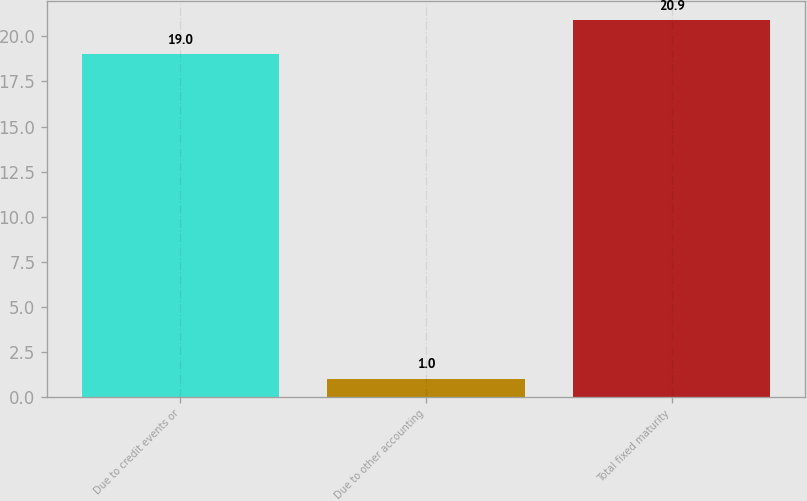Convert chart to OTSL. <chart><loc_0><loc_0><loc_500><loc_500><bar_chart><fcel>Due to credit events or<fcel>Due to other accounting<fcel>Total fixed maturity<nl><fcel>19<fcel>1<fcel>20.9<nl></chart> 